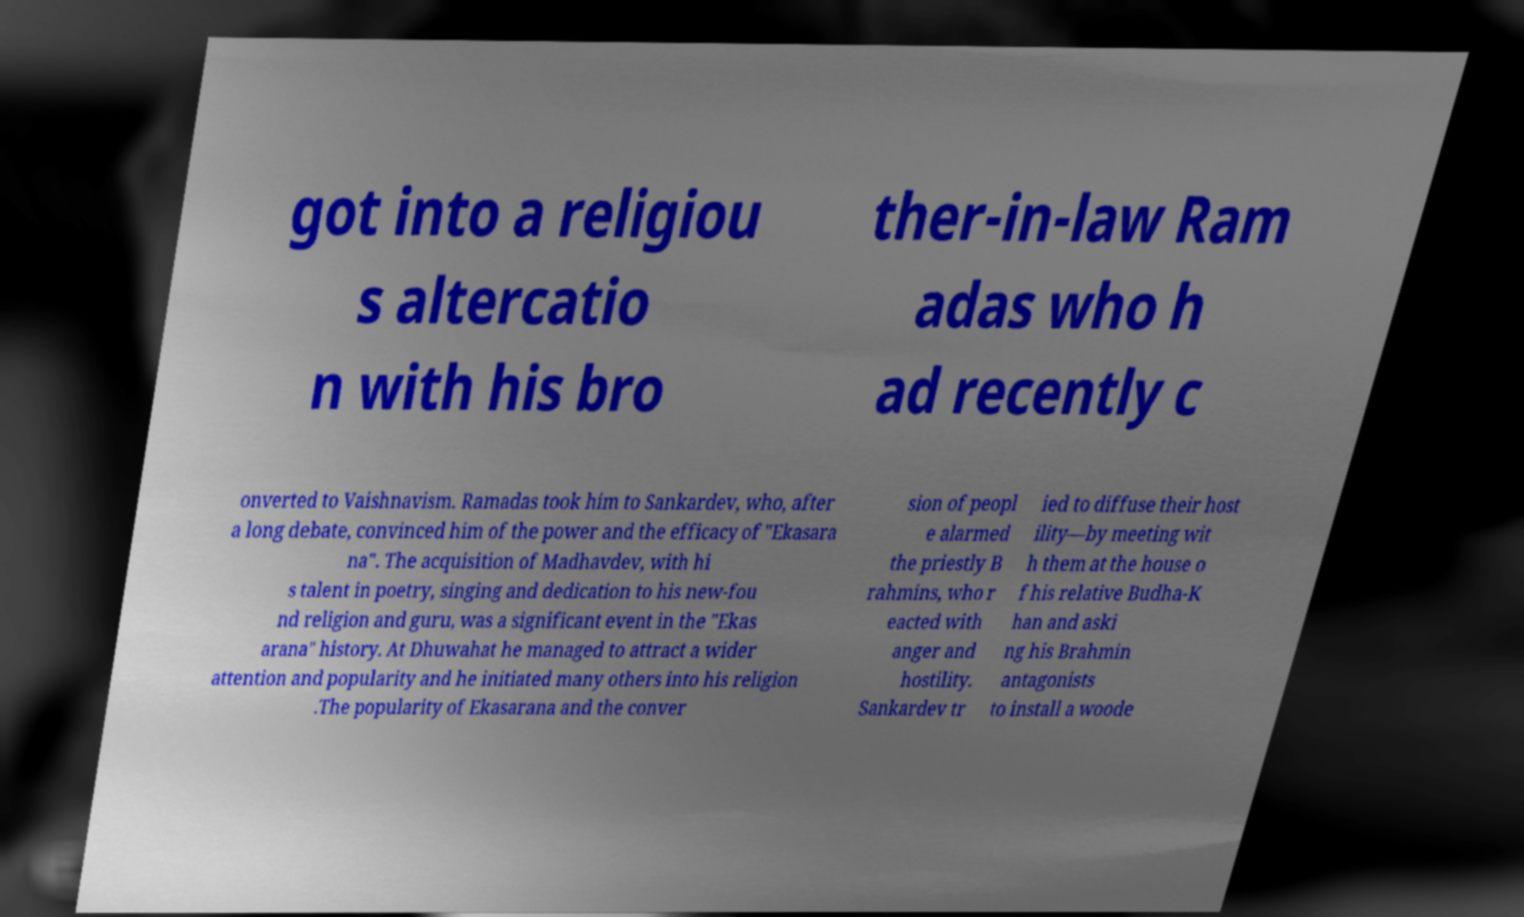Please read and relay the text visible in this image. What does it say? got into a religiou s altercatio n with his bro ther-in-law Ram adas who h ad recently c onverted to Vaishnavism. Ramadas took him to Sankardev, who, after a long debate, convinced him of the power and the efficacy of "Ekasara na". The acquisition of Madhavdev, with hi s talent in poetry, singing and dedication to his new-fou nd religion and guru, was a significant event in the "Ekas arana" history. At Dhuwahat he managed to attract a wider attention and popularity and he initiated many others into his religion .The popularity of Ekasarana and the conver sion of peopl e alarmed the priestly B rahmins, who r eacted with anger and hostility. Sankardev tr ied to diffuse their host ility—by meeting wit h them at the house o f his relative Budha-K han and aski ng his Brahmin antagonists to install a woode 